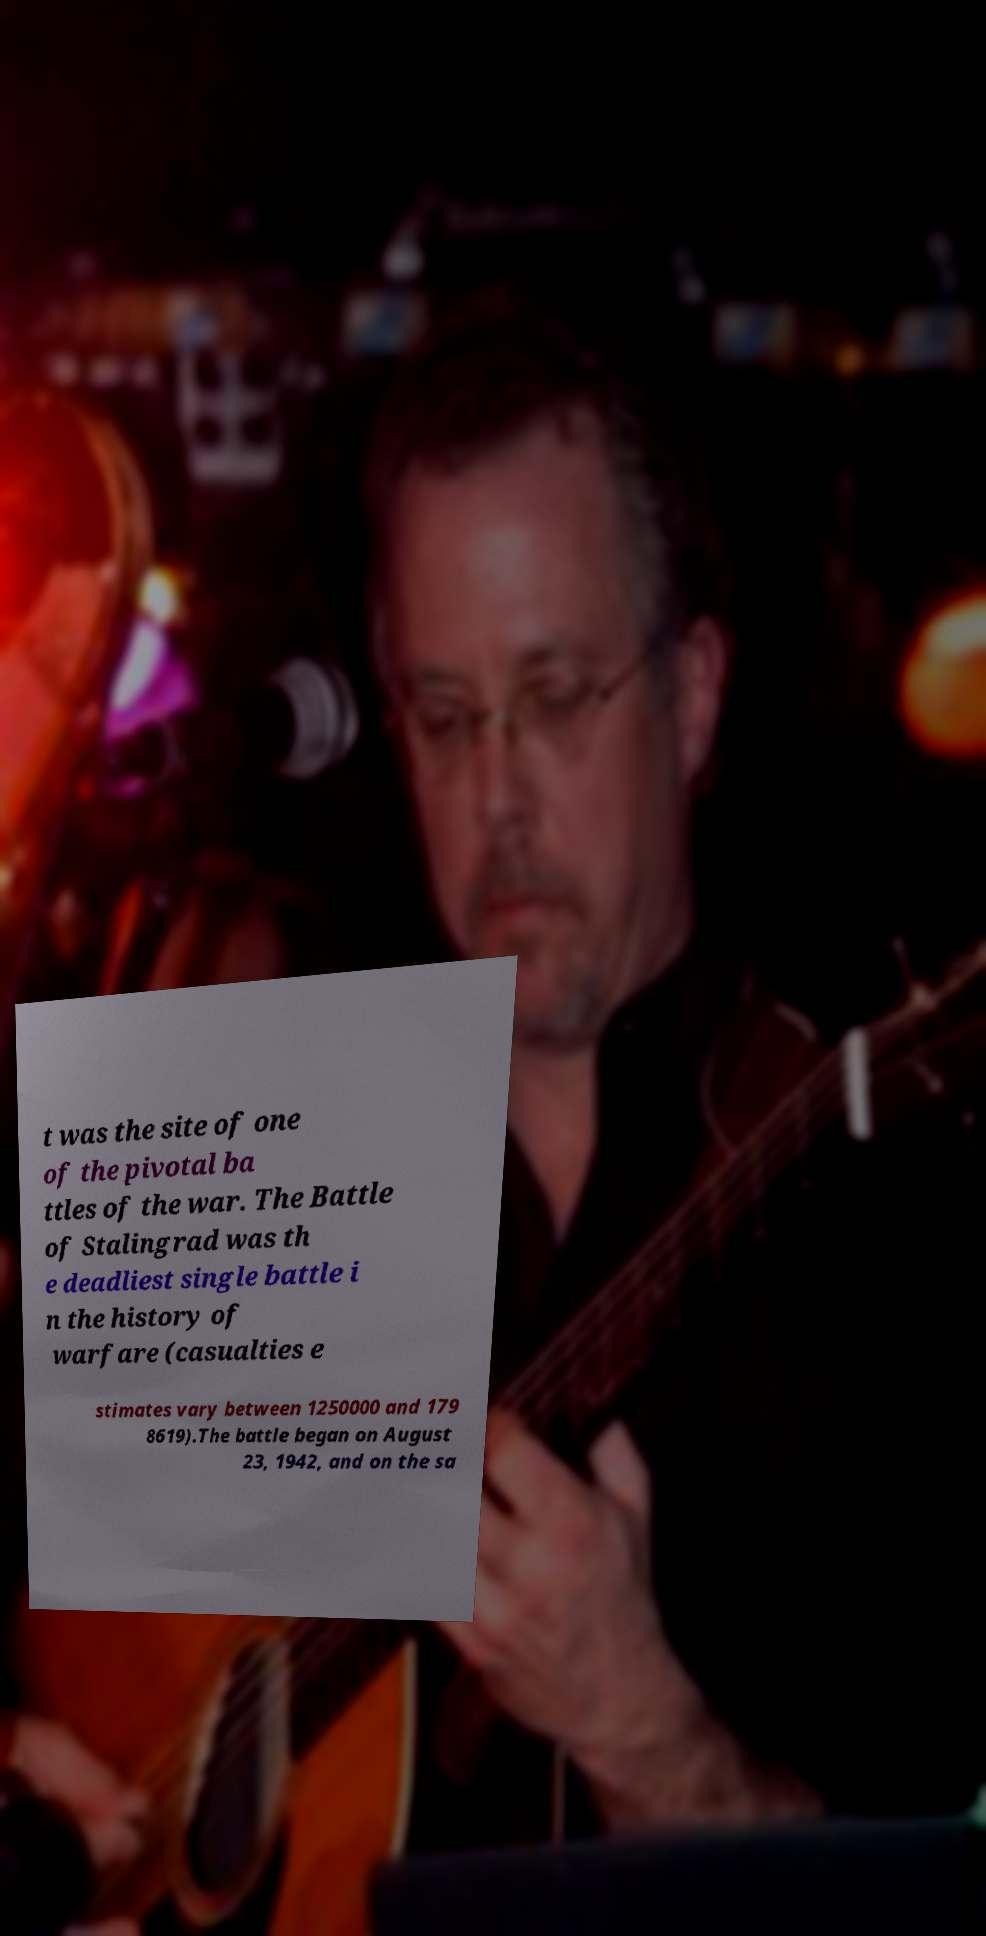Please read and relay the text visible in this image. What does it say? t was the site of one of the pivotal ba ttles of the war. The Battle of Stalingrad was th e deadliest single battle i n the history of warfare (casualties e stimates vary between 1250000 and 179 8619).The battle began on August 23, 1942, and on the sa 